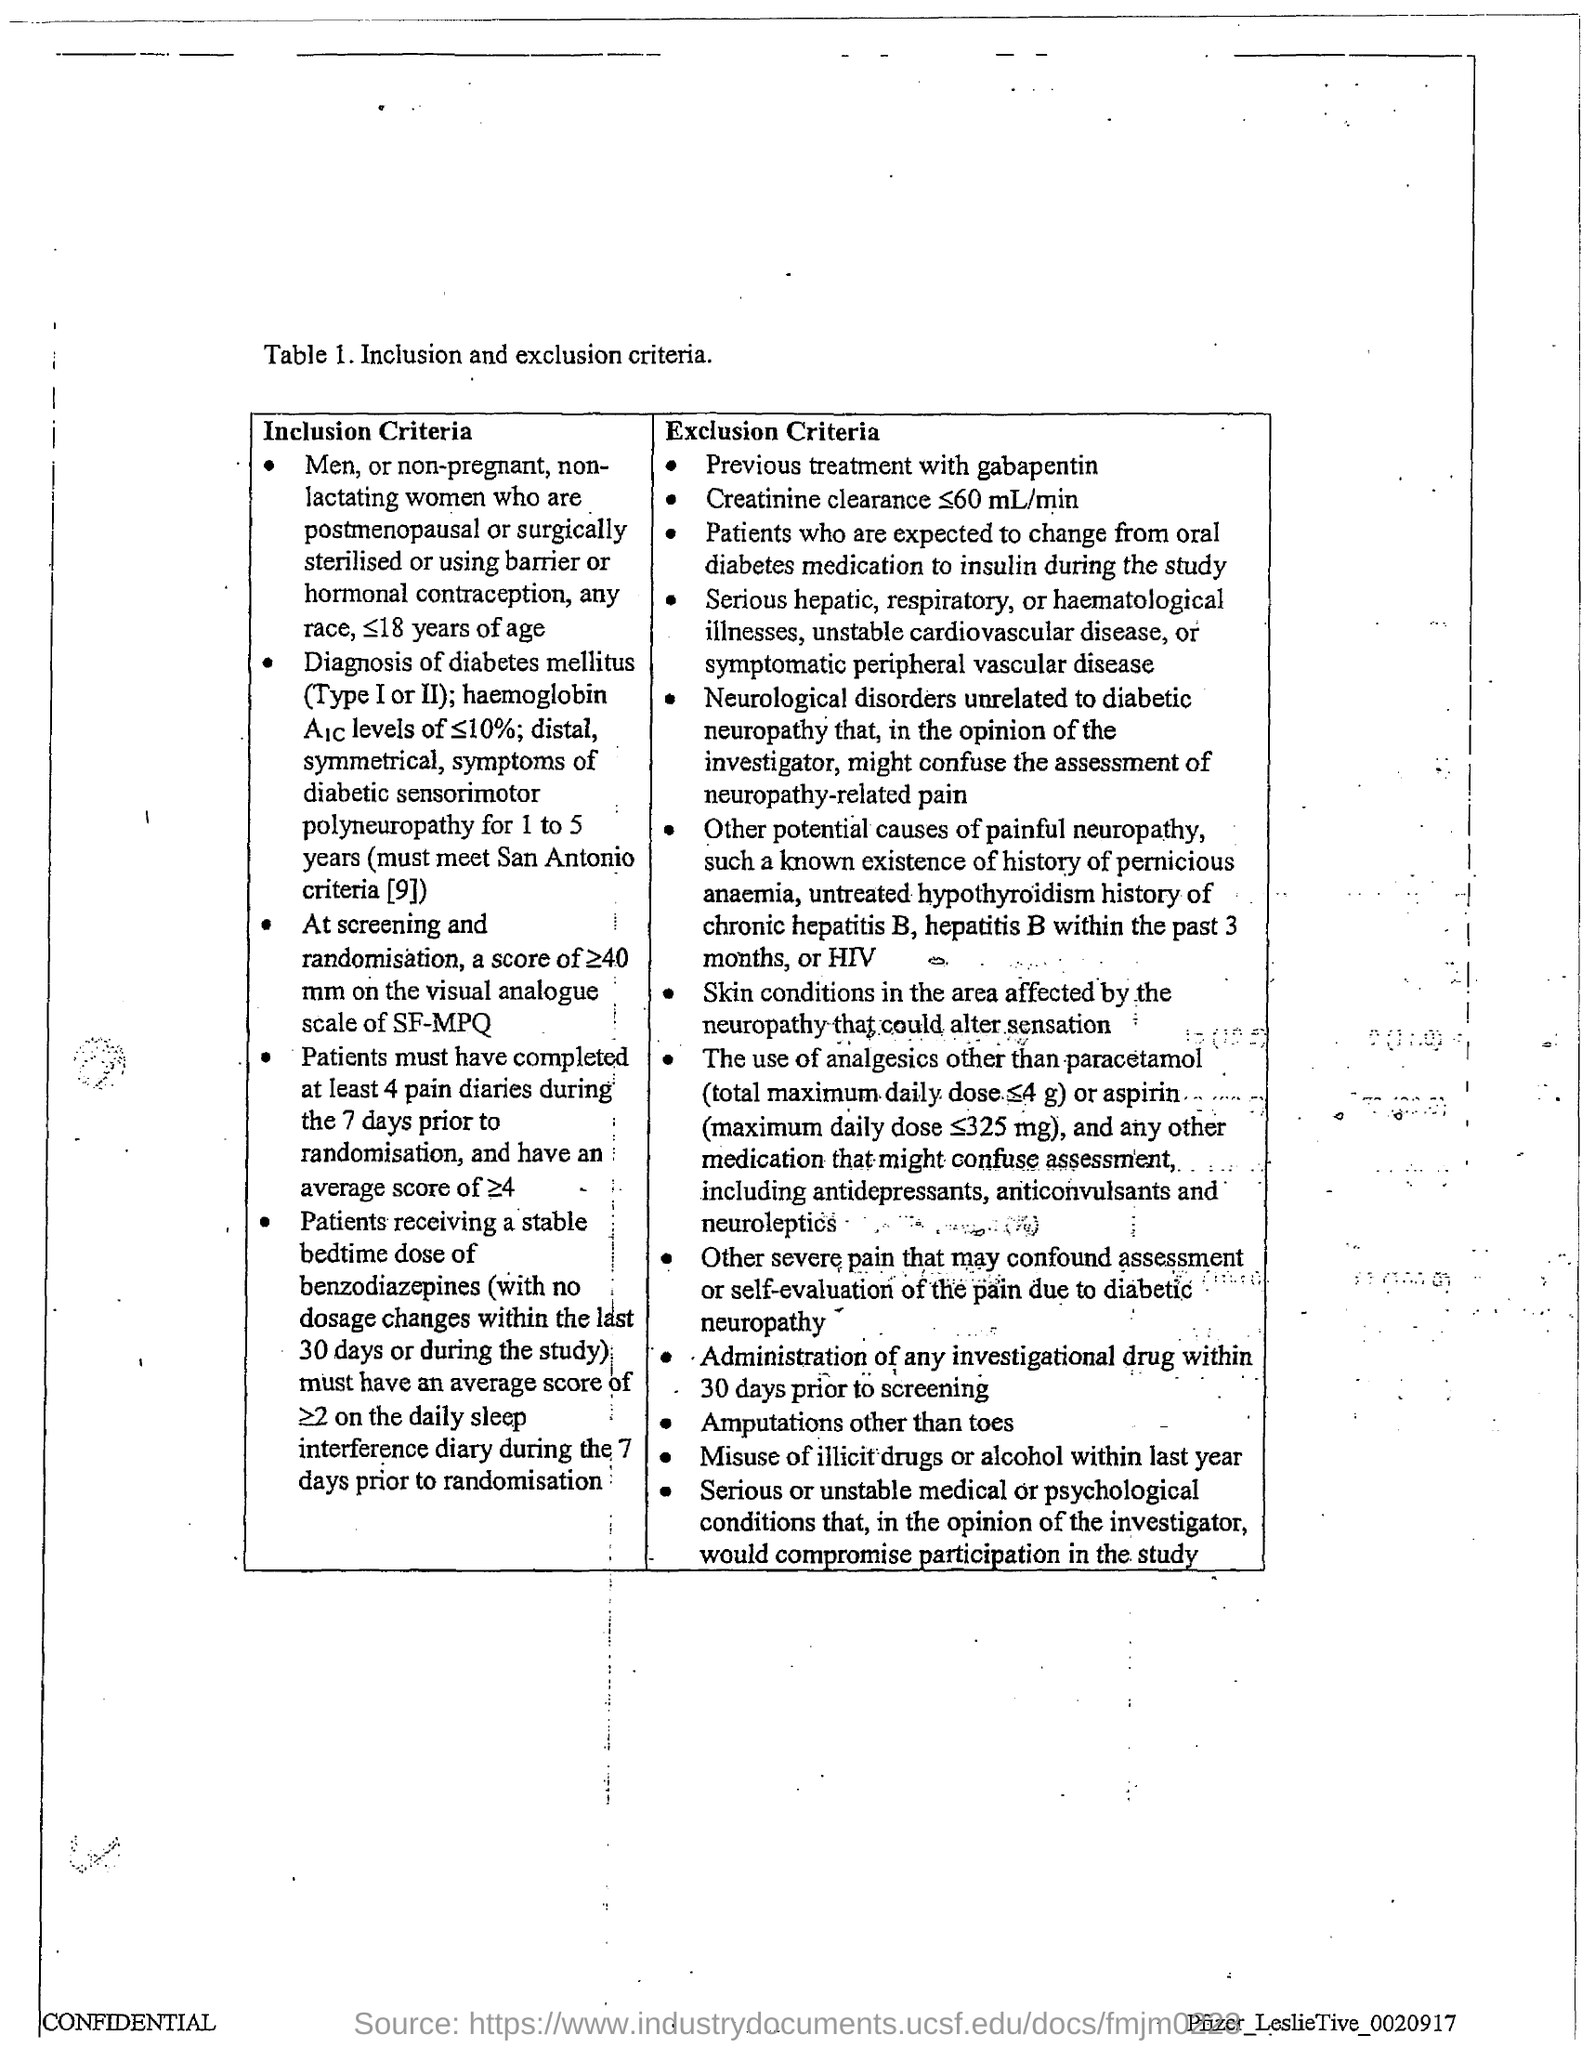What does Table 1. deal with?
Keep it short and to the point. Inclusion and exclusion criteria. 